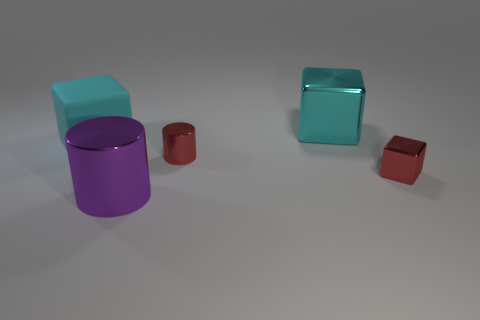How many large metallic things are the same color as the big matte object?
Keep it short and to the point. 1. There is a tiny object that is behind the small shiny block; does it have the same color as the big metal cylinder?
Provide a short and direct response. No. What number of cyan objects are either big cubes or cubes?
Ensure brevity in your answer.  2. How many other objects are there of the same shape as the large cyan rubber thing?
Give a very brief answer. 2. There is a thing that is left of the tiny cylinder and in front of the big cyan matte cube; what is its material?
Offer a terse response. Metal. The metal cylinder that is behind the red shiny cube is what color?
Give a very brief answer. Red. Is the number of red shiny things that are right of the red shiny cylinder greater than the number of big yellow shiny things?
Provide a succinct answer. Yes. How many other things are there of the same size as the cyan metallic object?
Your answer should be very brief. 2. What number of small things are on the left side of the red cube?
Your answer should be compact. 1. Are there the same number of blocks that are in front of the tiny cylinder and big cyan rubber blocks in front of the large rubber cube?
Offer a very short reply. No. 